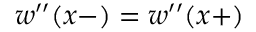Convert formula to latex. <formula><loc_0><loc_0><loc_500><loc_500>w ^ { \prime \prime } ( x - ) = w ^ { \prime \prime } ( x + )</formula> 